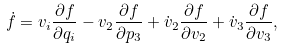Convert formula to latex. <formula><loc_0><loc_0><loc_500><loc_500>\dot { f } = v _ { i } \frac { \partial f } { \partial q _ { i } } - v _ { 2 } \frac { \partial f } { \partial p _ { 3 } } + \dot { v } _ { 2 } \frac { \partial f } { \partial v _ { 2 } } + \dot { v } _ { 3 } \frac { \partial f } { \partial v _ { 3 } } ,</formula> 